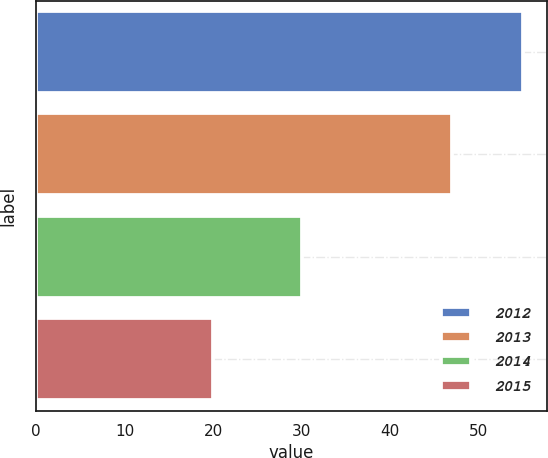Convert chart to OTSL. <chart><loc_0><loc_0><loc_500><loc_500><bar_chart><fcel>2012<fcel>2013<fcel>2014<fcel>2015<nl><fcel>55<fcel>47<fcel>30<fcel>20<nl></chart> 